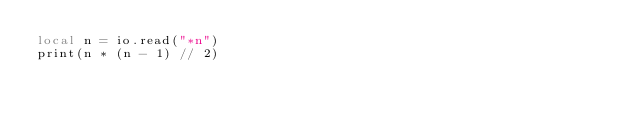<code> <loc_0><loc_0><loc_500><loc_500><_Lua_>local n = io.read("*n")
print(n * (n - 1) // 2)
</code> 